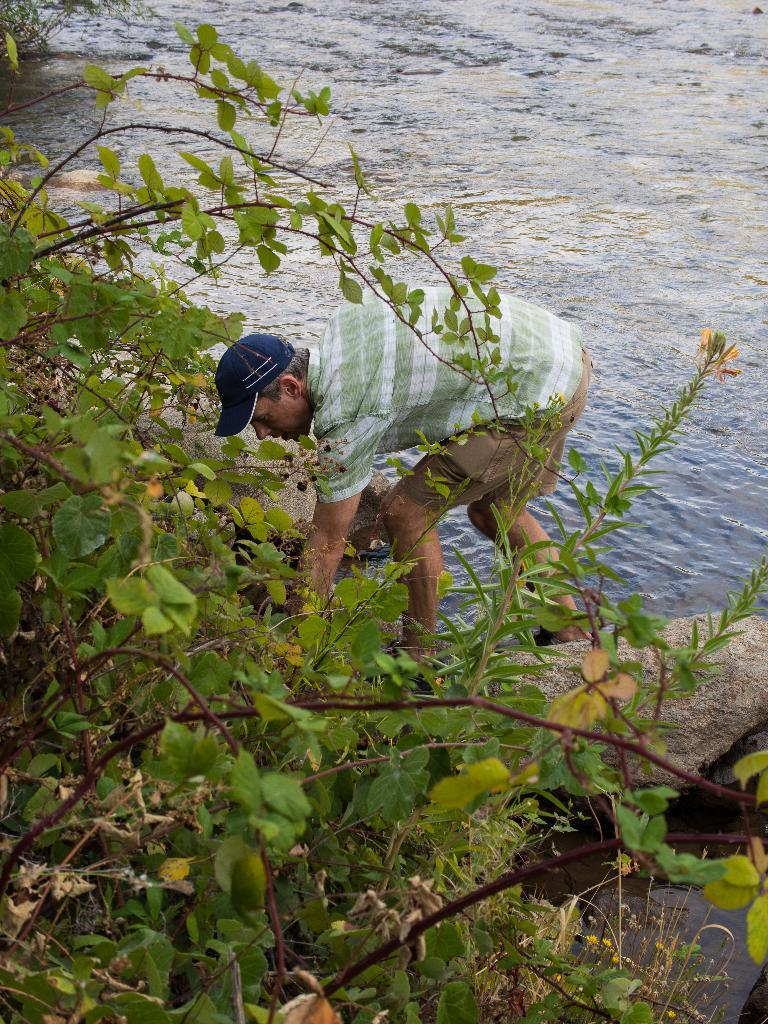What type of natural elements can be seen in the image? There are trees and rocks in the image. What is the water feature in the image? There is water visible in the image. Can you describe the person in the image? There is a man wearing a cap in the image. What type of furniture can be seen in the image? There is no furniture present in the image. How many feet are visible in the image? There is no reference to feet or any body parts in the image. 